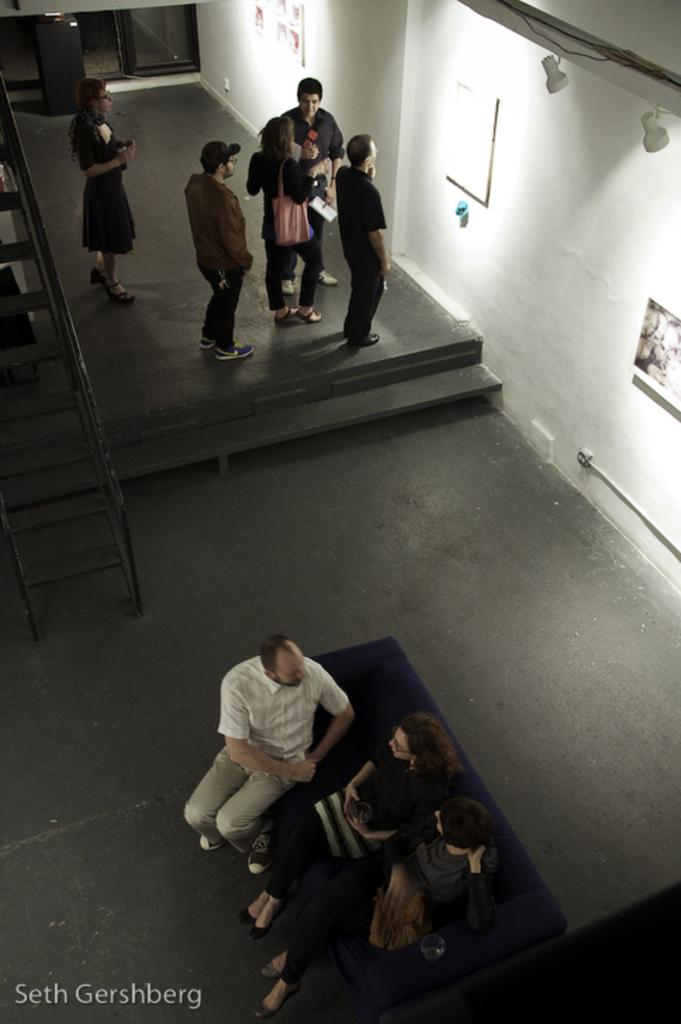What are the people in the image doing? There are people standing and sitting on a couch in the image. What can be seen on the wall in the image? There are pictures on the wall in the image. What color is the wall in the image? The wall in the image is white-colored. How many frogs are sitting on the couch in the image? There are no frogs present in the image; it features people standing and sitting on a couch. What type of finger can be seen pointing at the pictures on the wall? There are no fingers visible in the image pointing at the pictures on the wall. 